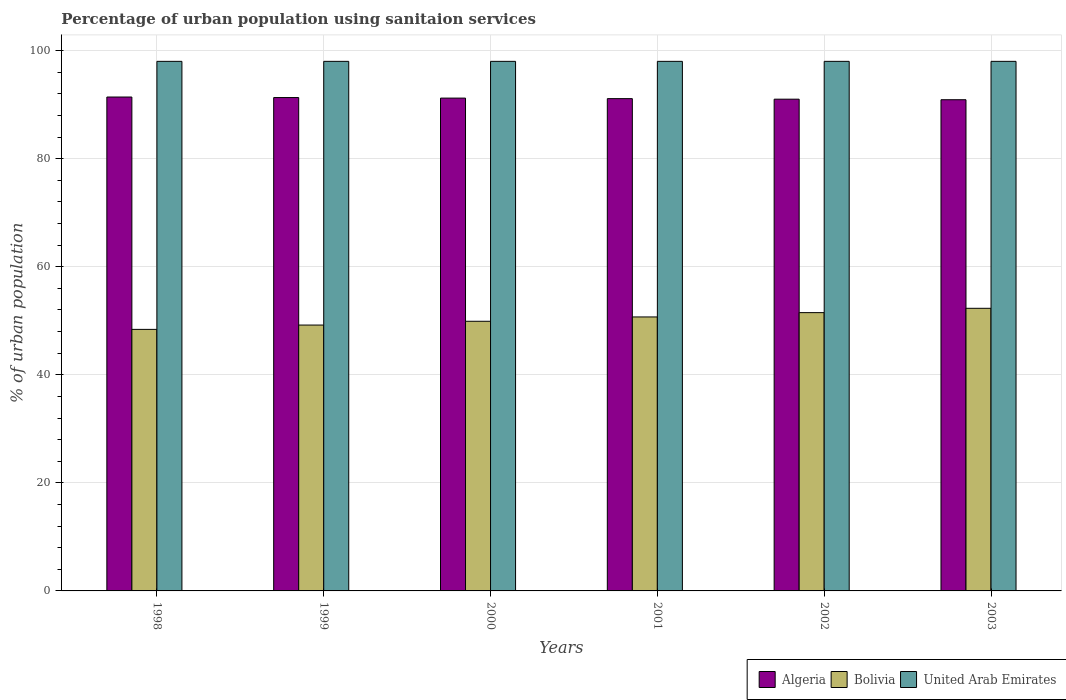Are the number of bars per tick equal to the number of legend labels?
Make the answer very short. Yes. Are the number of bars on each tick of the X-axis equal?
Give a very brief answer. Yes. What is the label of the 3rd group of bars from the left?
Your answer should be very brief. 2000. In how many cases, is the number of bars for a given year not equal to the number of legend labels?
Provide a succinct answer. 0. What is the percentage of urban population using sanitaion services in Algeria in 2003?
Your response must be concise. 90.9. Across all years, what is the maximum percentage of urban population using sanitaion services in United Arab Emirates?
Provide a succinct answer. 98. Across all years, what is the minimum percentage of urban population using sanitaion services in United Arab Emirates?
Keep it short and to the point. 98. In which year was the percentage of urban population using sanitaion services in United Arab Emirates maximum?
Your response must be concise. 1998. What is the total percentage of urban population using sanitaion services in Bolivia in the graph?
Your response must be concise. 302. What is the difference between the percentage of urban population using sanitaion services in Bolivia in 1998 and that in 2003?
Keep it short and to the point. -3.9. What is the difference between the percentage of urban population using sanitaion services in Bolivia in 2003 and the percentage of urban population using sanitaion services in United Arab Emirates in 1999?
Provide a succinct answer. -45.7. What is the average percentage of urban population using sanitaion services in Algeria per year?
Your response must be concise. 91.15. In the year 1999, what is the difference between the percentage of urban population using sanitaion services in Algeria and percentage of urban population using sanitaion services in United Arab Emirates?
Make the answer very short. -6.7. In how many years, is the percentage of urban population using sanitaion services in United Arab Emirates greater than 68 %?
Offer a terse response. 6. What is the ratio of the percentage of urban population using sanitaion services in United Arab Emirates in 2000 to that in 2003?
Offer a very short reply. 1. What is the difference between the highest and the second highest percentage of urban population using sanitaion services in Algeria?
Offer a very short reply. 0.1. What is the difference between the highest and the lowest percentage of urban population using sanitaion services in United Arab Emirates?
Provide a succinct answer. 0. In how many years, is the percentage of urban population using sanitaion services in Algeria greater than the average percentage of urban population using sanitaion services in Algeria taken over all years?
Offer a terse response. 3. What does the 3rd bar from the left in 2000 represents?
Provide a short and direct response. United Arab Emirates. What does the 3rd bar from the right in 2000 represents?
Ensure brevity in your answer.  Algeria. How many years are there in the graph?
Ensure brevity in your answer.  6. Are the values on the major ticks of Y-axis written in scientific E-notation?
Make the answer very short. No. Does the graph contain grids?
Offer a very short reply. Yes. Where does the legend appear in the graph?
Provide a succinct answer. Bottom right. How many legend labels are there?
Provide a short and direct response. 3. How are the legend labels stacked?
Offer a very short reply. Horizontal. What is the title of the graph?
Provide a short and direct response. Percentage of urban population using sanitaion services. What is the label or title of the Y-axis?
Offer a terse response. % of urban population. What is the % of urban population in Algeria in 1998?
Give a very brief answer. 91.4. What is the % of urban population in Bolivia in 1998?
Your answer should be very brief. 48.4. What is the % of urban population in Algeria in 1999?
Ensure brevity in your answer.  91.3. What is the % of urban population in Bolivia in 1999?
Ensure brevity in your answer.  49.2. What is the % of urban population in Algeria in 2000?
Your response must be concise. 91.2. What is the % of urban population in Bolivia in 2000?
Your response must be concise. 49.9. What is the % of urban population in United Arab Emirates in 2000?
Ensure brevity in your answer.  98. What is the % of urban population in Algeria in 2001?
Your answer should be very brief. 91.1. What is the % of urban population in Bolivia in 2001?
Make the answer very short. 50.7. What is the % of urban population of Algeria in 2002?
Your response must be concise. 91. What is the % of urban population of Bolivia in 2002?
Make the answer very short. 51.5. What is the % of urban population in United Arab Emirates in 2002?
Your answer should be compact. 98. What is the % of urban population of Algeria in 2003?
Keep it short and to the point. 90.9. What is the % of urban population in Bolivia in 2003?
Your answer should be compact. 52.3. Across all years, what is the maximum % of urban population in Algeria?
Make the answer very short. 91.4. Across all years, what is the maximum % of urban population in Bolivia?
Your response must be concise. 52.3. Across all years, what is the maximum % of urban population of United Arab Emirates?
Keep it short and to the point. 98. Across all years, what is the minimum % of urban population in Algeria?
Your response must be concise. 90.9. Across all years, what is the minimum % of urban population of Bolivia?
Provide a succinct answer. 48.4. Across all years, what is the minimum % of urban population in United Arab Emirates?
Ensure brevity in your answer.  98. What is the total % of urban population of Algeria in the graph?
Keep it short and to the point. 546.9. What is the total % of urban population in Bolivia in the graph?
Make the answer very short. 302. What is the total % of urban population in United Arab Emirates in the graph?
Keep it short and to the point. 588. What is the difference between the % of urban population in Bolivia in 1998 and that in 1999?
Your answer should be very brief. -0.8. What is the difference between the % of urban population of Algeria in 1998 and that in 2000?
Your response must be concise. 0.2. What is the difference between the % of urban population of Bolivia in 1998 and that in 2001?
Give a very brief answer. -2.3. What is the difference between the % of urban population in United Arab Emirates in 1998 and that in 2001?
Offer a very short reply. 0. What is the difference between the % of urban population of Algeria in 1998 and that in 2002?
Your response must be concise. 0.4. What is the difference between the % of urban population of Bolivia in 1998 and that in 2002?
Provide a succinct answer. -3.1. What is the difference between the % of urban population in Algeria in 1998 and that in 2003?
Your answer should be very brief. 0.5. What is the difference between the % of urban population of Bolivia in 1999 and that in 2000?
Keep it short and to the point. -0.7. What is the difference between the % of urban population of Algeria in 1999 and that in 2001?
Give a very brief answer. 0.2. What is the difference between the % of urban population of Bolivia in 1999 and that in 2001?
Your answer should be compact. -1.5. What is the difference between the % of urban population of Bolivia in 1999 and that in 2002?
Make the answer very short. -2.3. What is the difference between the % of urban population in Algeria in 2000 and that in 2001?
Offer a terse response. 0.1. What is the difference between the % of urban population of Algeria in 2000 and that in 2002?
Make the answer very short. 0.2. What is the difference between the % of urban population in United Arab Emirates in 2000 and that in 2002?
Offer a terse response. 0. What is the difference between the % of urban population in Bolivia in 2001 and that in 2002?
Offer a very short reply. -0.8. What is the difference between the % of urban population of Bolivia in 2001 and that in 2003?
Provide a succinct answer. -1.6. What is the difference between the % of urban population in United Arab Emirates in 2001 and that in 2003?
Give a very brief answer. 0. What is the difference between the % of urban population in Algeria in 2002 and that in 2003?
Make the answer very short. 0.1. What is the difference between the % of urban population in United Arab Emirates in 2002 and that in 2003?
Make the answer very short. 0. What is the difference between the % of urban population in Algeria in 1998 and the % of urban population in Bolivia in 1999?
Provide a short and direct response. 42.2. What is the difference between the % of urban population in Bolivia in 1998 and the % of urban population in United Arab Emirates in 1999?
Ensure brevity in your answer.  -49.6. What is the difference between the % of urban population in Algeria in 1998 and the % of urban population in Bolivia in 2000?
Your response must be concise. 41.5. What is the difference between the % of urban population in Bolivia in 1998 and the % of urban population in United Arab Emirates in 2000?
Provide a short and direct response. -49.6. What is the difference between the % of urban population of Algeria in 1998 and the % of urban population of Bolivia in 2001?
Your answer should be very brief. 40.7. What is the difference between the % of urban population in Algeria in 1998 and the % of urban population in United Arab Emirates in 2001?
Offer a terse response. -6.6. What is the difference between the % of urban population of Bolivia in 1998 and the % of urban population of United Arab Emirates in 2001?
Ensure brevity in your answer.  -49.6. What is the difference between the % of urban population in Algeria in 1998 and the % of urban population in Bolivia in 2002?
Offer a very short reply. 39.9. What is the difference between the % of urban population of Algeria in 1998 and the % of urban population of United Arab Emirates in 2002?
Keep it short and to the point. -6.6. What is the difference between the % of urban population in Bolivia in 1998 and the % of urban population in United Arab Emirates in 2002?
Give a very brief answer. -49.6. What is the difference between the % of urban population in Algeria in 1998 and the % of urban population in Bolivia in 2003?
Offer a very short reply. 39.1. What is the difference between the % of urban population in Bolivia in 1998 and the % of urban population in United Arab Emirates in 2003?
Provide a succinct answer. -49.6. What is the difference between the % of urban population of Algeria in 1999 and the % of urban population of Bolivia in 2000?
Your answer should be compact. 41.4. What is the difference between the % of urban population of Bolivia in 1999 and the % of urban population of United Arab Emirates in 2000?
Provide a short and direct response. -48.8. What is the difference between the % of urban population in Algeria in 1999 and the % of urban population in Bolivia in 2001?
Ensure brevity in your answer.  40.6. What is the difference between the % of urban population of Algeria in 1999 and the % of urban population of United Arab Emirates in 2001?
Give a very brief answer. -6.7. What is the difference between the % of urban population in Bolivia in 1999 and the % of urban population in United Arab Emirates in 2001?
Keep it short and to the point. -48.8. What is the difference between the % of urban population in Algeria in 1999 and the % of urban population in Bolivia in 2002?
Your response must be concise. 39.8. What is the difference between the % of urban population of Algeria in 1999 and the % of urban population of United Arab Emirates in 2002?
Offer a very short reply. -6.7. What is the difference between the % of urban population of Bolivia in 1999 and the % of urban population of United Arab Emirates in 2002?
Your answer should be compact. -48.8. What is the difference between the % of urban population in Algeria in 1999 and the % of urban population in United Arab Emirates in 2003?
Give a very brief answer. -6.7. What is the difference between the % of urban population in Bolivia in 1999 and the % of urban population in United Arab Emirates in 2003?
Your answer should be very brief. -48.8. What is the difference between the % of urban population in Algeria in 2000 and the % of urban population in Bolivia in 2001?
Offer a very short reply. 40.5. What is the difference between the % of urban population of Algeria in 2000 and the % of urban population of United Arab Emirates in 2001?
Your answer should be very brief. -6.8. What is the difference between the % of urban population in Bolivia in 2000 and the % of urban population in United Arab Emirates in 2001?
Your answer should be very brief. -48.1. What is the difference between the % of urban population of Algeria in 2000 and the % of urban population of Bolivia in 2002?
Give a very brief answer. 39.7. What is the difference between the % of urban population in Bolivia in 2000 and the % of urban population in United Arab Emirates in 2002?
Offer a very short reply. -48.1. What is the difference between the % of urban population in Algeria in 2000 and the % of urban population in Bolivia in 2003?
Give a very brief answer. 38.9. What is the difference between the % of urban population of Bolivia in 2000 and the % of urban population of United Arab Emirates in 2003?
Offer a terse response. -48.1. What is the difference between the % of urban population in Algeria in 2001 and the % of urban population in Bolivia in 2002?
Provide a succinct answer. 39.6. What is the difference between the % of urban population in Bolivia in 2001 and the % of urban population in United Arab Emirates in 2002?
Ensure brevity in your answer.  -47.3. What is the difference between the % of urban population of Algeria in 2001 and the % of urban population of Bolivia in 2003?
Offer a very short reply. 38.8. What is the difference between the % of urban population in Bolivia in 2001 and the % of urban population in United Arab Emirates in 2003?
Ensure brevity in your answer.  -47.3. What is the difference between the % of urban population of Algeria in 2002 and the % of urban population of Bolivia in 2003?
Offer a very short reply. 38.7. What is the difference between the % of urban population in Algeria in 2002 and the % of urban population in United Arab Emirates in 2003?
Ensure brevity in your answer.  -7. What is the difference between the % of urban population of Bolivia in 2002 and the % of urban population of United Arab Emirates in 2003?
Keep it short and to the point. -46.5. What is the average % of urban population of Algeria per year?
Provide a short and direct response. 91.15. What is the average % of urban population of Bolivia per year?
Provide a short and direct response. 50.33. In the year 1998, what is the difference between the % of urban population of Algeria and % of urban population of Bolivia?
Offer a very short reply. 43. In the year 1998, what is the difference between the % of urban population of Algeria and % of urban population of United Arab Emirates?
Provide a succinct answer. -6.6. In the year 1998, what is the difference between the % of urban population in Bolivia and % of urban population in United Arab Emirates?
Provide a succinct answer. -49.6. In the year 1999, what is the difference between the % of urban population of Algeria and % of urban population of Bolivia?
Your response must be concise. 42.1. In the year 1999, what is the difference between the % of urban population in Bolivia and % of urban population in United Arab Emirates?
Offer a terse response. -48.8. In the year 2000, what is the difference between the % of urban population of Algeria and % of urban population of Bolivia?
Offer a terse response. 41.3. In the year 2000, what is the difference between the % of urban population in Algeria and % of urban population in United Arab Emirates?
Your answer should be very brief. -6.8. In the year 2000, what is the difference between the % of urban population of Bolivia and % of urban population of United Arab Emirates?
Your answer should be compact. -48.1. In the year 2001, what is the difference between the % of urban population in Algeria and % of urban population in Bolivia?
Offer a very short reply. 40.4. In the year 2001, what is the difference between the % of urban population in Algeria and % of urban population in United Arab Emirates?
Ensure brevity in your answer.  -6.9. In the year 2001, what is the difference between the % of urban population of Bolivia and % of urban population of United Arab Emirates?
Offer a terse response. -47.3. In the year 2002, what is the difference between the % of urban population of Algeria and % of urban population of Bolivia?
Your answer should be compact. 39.5. In the year 2002, what is the difference between the % of urban population in Algeria and % of urban population in United Arab Emirates?
Your response must be concise. -7. In the year 2002, what is the difference between the % of urban population of Bolivia and % of urban population of United Arab Emirates?
Ensure brevity in your answer.  -46.5. In the year 2003, what is the difference between the % of urban population in Algeria and % of urban population in Bolivia?
Provide a short and direct response. 38.6. In the year 2003, what is the difference between the % of urban population in Bolivia and % of urban population in United Arab Emirates?
Provide a short and direct response. -45.7. What is the ratio of the % of urban population in Algeria in 1998 to that in 1999?
Offer a terse response. 1. What is the ratio of the % of urban population in Bolivia in 1998 to that in 1999?
Ensure brevity in your answer.  0.98. What is the ratio of the % of urban population in United Arab Emirates in 1998 to that in 1999?
Provide a short and direct response. 1. What is the ratio of the % of urban population in Algeria in 1998 to that in 2000?
Ensure brevity in your answer.  1. What is the ratio of the % of urban population in Bolivia in 1998 to that in 2000?
Make the answer very short. 0.97. What is the ratio of the % of urban population in Bolivia in 1998 to that in 2001?
Your response must be concise. 0.95. What is the ratio of the % of urban population in United Arab Emirates in 1998 to that in 2001?
Your answer should be compact. 1. What is the ratio of the % of urban population in Algeria in 1998 to that in 2002?
Your answer should be compact. 1. What is the ratio of the % of urban population of Bolivia in 1998 to that in 2002?
Ensure brevity in your answer.  0.94. What is the ratio of the % of urban population in Bolivia in 1998 to that in 2003?
Ensure brevity in your answer.  0.93. What is the ratio of the % of urban population in United Arab Emirates in 1998 to that in 2003?
Your answer should be compact. 1. What is the ratio of the % of urban population of Algeria in 1999 to that in 2000?
Ensure brevity in your answer.  1. What is the ratio of the % of urban population in Bolivia in 1999 to that in 2000?
Offer a very short reply. 0.99. What is the ratio of the % of urban population of Bolivia in 1999 to that in 2001?
Offer a terse response. 0.97. What is the ratio of the % of urban population of United Arab Emirates in 1999 to that in 2001?
Provide a succinct answer. 1. What is the ratio of the % of urban population of Algeria in 1999 to that in 2002?
Ensure brevity in your answer.  1. What is the ratio of the % of urban population of Bolivia in 1999 to that in 2002?
Offer a very short reply. 0.96. What is the ratio of the % of urban population of United Arab Emirates in 1999 to that in 2002?
Provide a short and direct response. 1. What is the ratio of the % of urban population in Bolivia in 1999 to that in 2003?
Provide a short and direct response. 0.94. What is the ratio of the % of urban population in United Arab Emirates in 1999 to that in 2003?
Ensure brevity in your answer.  1. What is the ratio of the % of urban population in Bolivia in 2000 to that in 2001?
Your answer should be very brief. 0.98. What is the ratio of the % of urban population in Algeria in 2000 to that in 2002?
Keep it short and to the point. 1. What is the ratio of the % of urban population of Bolivia in 2000 to that in 2002?
Offer a very short reply. 0.97. What is the ratio of the % of urban population in Algeria in 2000 to that in 2003?
Provide a short and direct response. 1. What is the ratio of the % of urban population in Bolivia in 2000 to that in 2003?
Ensure brevity in your answer.  0.95. What is the ratio of the % of urban population of Algeria in 2001 to that in 2002?
Your answer should be very brief. 1. What is the ratio of the % of urban population in Bolivia in 2001 to that in 2002?
Make the answer very short. 0.98. What is the ratio of the % of urban population in United Arab Emirates in 2001 to that in 2002?
Your response must be concise. 1. What is the ratio of the % of urban population of Bolivia in 2001 to that in 2003?
Make the answer very short. 0.97. What is the ratio of the % of urban population of Algeria in 2002 to that in 2003?
Make the answer very short. 1. What is the ratio of the % of urban population in Bolivia in 2002 to that in 2003?
Your answer should be very brief. 0.98. What is the ratio of the % of urban population of United Arab Emirates in 2002 to that in 2003?
Your answer should be compact. 1. What is the difference between the highest and the lowest % of urban population of Bolivia?
Your answer should be compact. 3.9. What is the difference between the highest and the lowest % of urban population of United Arab Emirates?
Your answer should be compact. 0. 